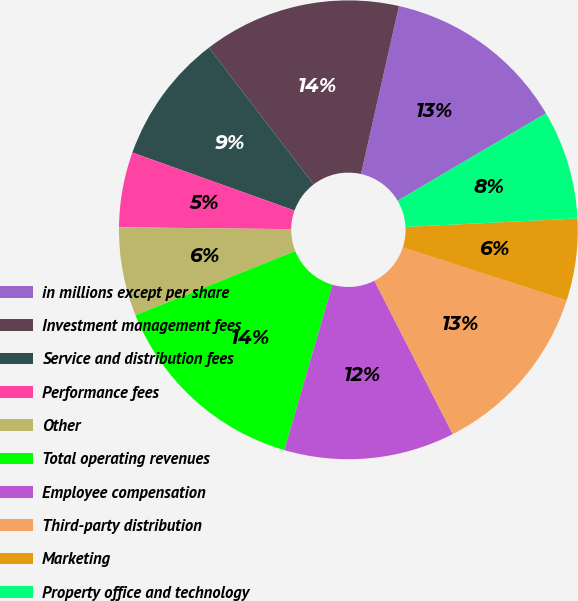Convert chart to OTSL. <chart><loc_0><loc_0><loc_500><loc_500><pie_chart><fcel>in millions except per share<fcel>Investment management fees<fcel>Service and distribution fees<fcel>Performance fees<fcel>Other<fcel>Total operating revenues<fcel>Employee compensation<fcel>Third-party distribution<fcel>Marketing<fcel>Property office and technology<nl><fcel>12.98%<fcel>13.94%<fcel>9.13%<fcel>5.29%<fcel>6.25%<fcel>14.42%<fcel>12.02%<fcel>12.5%<fcel>5.77%<fcel>7.69%<nl></chart> 